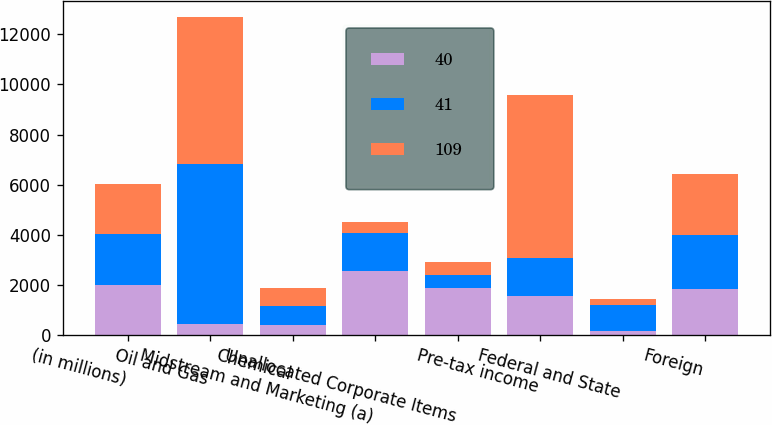<chart> <loc_0><loc_0><loc_500><loc_500><stacked_bar_chart><ecel><fcel>(in millions)<fcel>Oil and Gas<fcel>Chemical<fcel>Midstream and Marketing (a)<fcel>Unallocated Corporate Items<fcel>Pre-tax income<fcel>Federal and State<fcel>Foreign<nl><fcel>40<fcel>2014<fcel>428<fcel>420<fcel>2564<fcel>1871<fcel>1541<fcel>157<fcel>1842<nl><fcel>41<fcel>2013<fcel>6411<fcel>743<fcel>1523<fcel>531<fcel>1541<fcel>1061<fcel>2153<nl><fcel>109<fcel>2012<fcel>5840<fcel>720<fcel>440<fcel>512<fcel>6488<fcel>235<fcel>2424<nl></chart> 